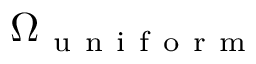Convert formula to latex. <formula><loc_0><loc_0><loc_500><loc_500>\Omega _ { u n i f o r m }</formula> 